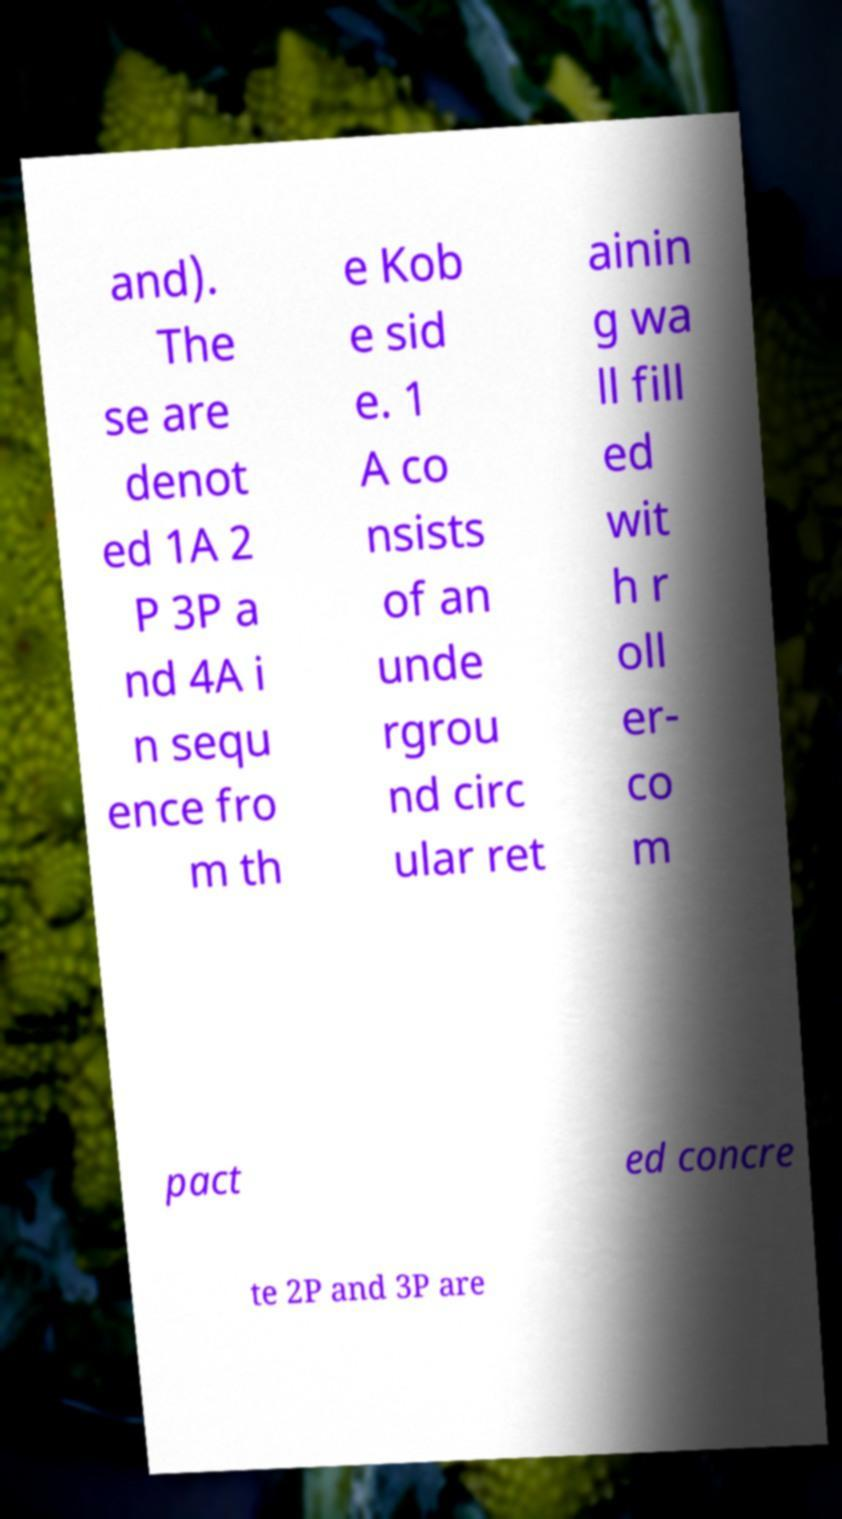Could you assist in decoding the text presented in this image and type it out clearly? and). The se are denot ed 1A 2 P 3P a nd 4A i n sequ ence fro m th e Kob e sid e. 1 A co nsists of an unde rgrou nd circ ular ret ainin g wa ll fill ed wit h r oll er- co m pact ed concre te 2P and 3P are 